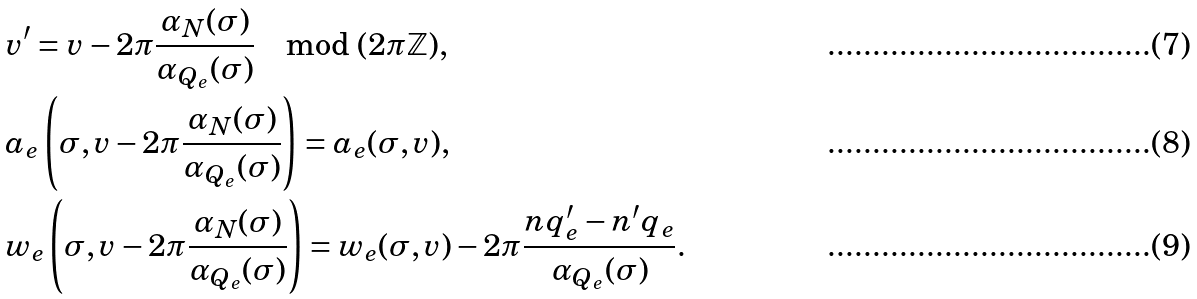<formula> <loc_0><loc_0><loc_500><loc_500>& v ^ { \prime } = v - 2 \pi \frac { \alpha _ { N } ( \sigma ) } { \alpha _ { Q _ { e } } ( \sigma ) } \mod ( 2 \pi \mathbb { Z } ) , \\ & a _ { e } \left ( \sigma , v - 2 \pi \frac { \alpha _ { N } ( \sigma ) } { \alpha _ { Q _ { e } } ( \sigma ) } \right ) = a _ { e } ( \sigma , v ) , \\ & w _ { e } \left ( \sigma , v - 2 \pi \frac { \alpha _ { N } ( \sigma ) } { \alpha _ { Q _ { e } } ( \sigma ) } \right ) = w _ { e } ( \sigma , v ) - 2 \pi \frac { n q _ { e } ^ { \prime } - n ^ { \prime } q _ { e } } { \alpha _ { Q _ { e } } ( \sigma ) } .</formula> 